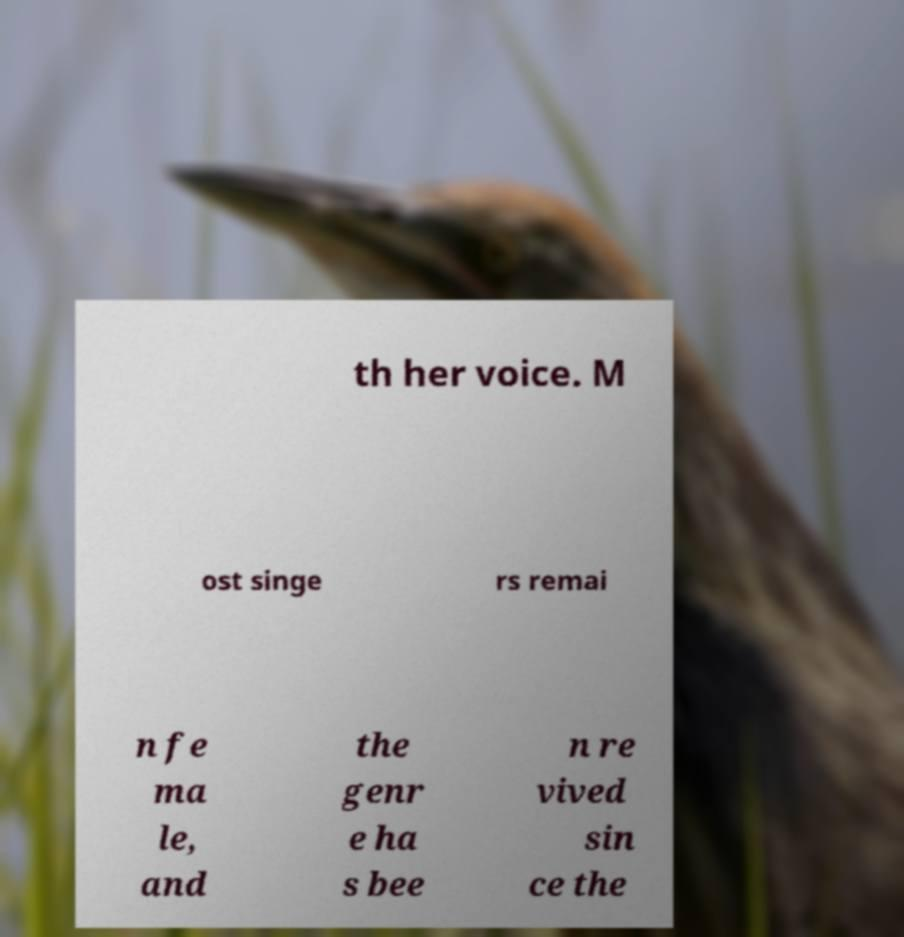What messages or text are displayed in this image? I need them in a readable, typed format. th her voice. M ost singe rs remai n fe ma le, and the genr e ha s bee n re vived sin ce the 